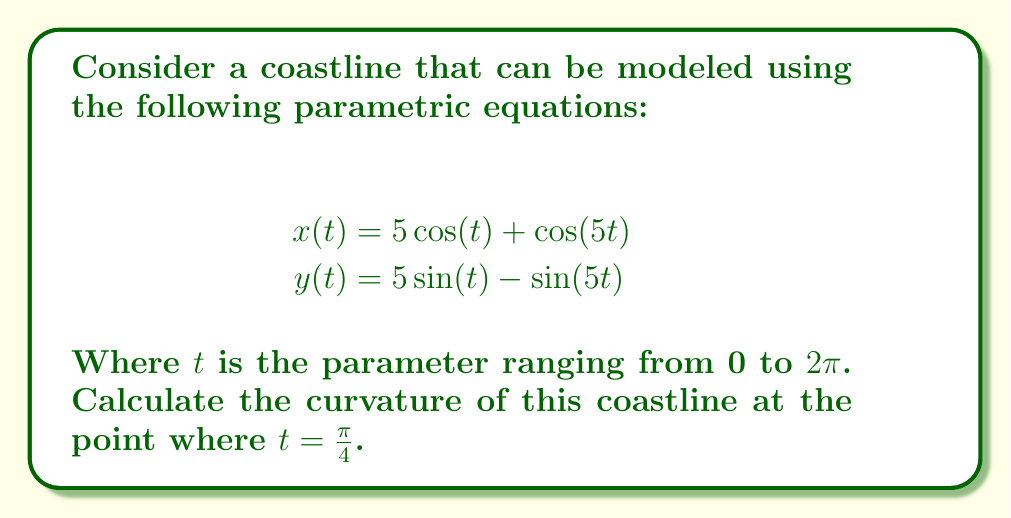Can you solve this math problem? To solve this problem, we'll follow these steps:

1) The formula for curvature ($\kappa$) of a parametric curve is:

   $$\kappa = \frac{|x'y'' - y'x''|}{(x'^2 + y'^2)^{3/2}}$$

2) Let's find the first and second derivatives of $x$ and $y$ with respect to $t$:

   $$x'(t) = -5\sin(t) - 5\sin(5t)$$
   $$y'(t) = 5\cos(t) - 5\cos(5t)$$
   $$x''(t) = -5\cos(t) - 25\cos(5t)$$
   $$y''(t) = -5\sin(t) + 25\sin(5t)$$

3) Now, we need to evaluate these at $t = \frac{\pi}{4}$:

   $$x'(\frac{\pi}{4}) = -5\sin(\frac{\pi}{4}) - 5\sin(\frac{5\pi}{4}) = -\frac{5\sqrt{2}}{2} + \frac{5\sqrt{2}}{2} = 0$$
   $$y'(\frac{\pi}{4}) = 5\cos(\frac{\pi}{4}) - 5\cos(\frac{5\pi}{4}) = \frac{5\sqrt{2}}{2} + \frac{5\sqrt{2}}{2} = 5\sqrt{2}$$
   $$x''(\frac{\pi}{4}) = -5\cos(\frac{\pi}{4}) - 25\cos(\frac{5\pi}{4}) = -\frac{5\sqrt{2}}{2} + \frac{25\sqrt{2}}{2} = 10\sqrt{2}$$
   $$y''(\frac{\pi}{4}) = -5\sin(\frac{\pi}{4}) + 25\sin(\frac{5\pi}{4}) = -\frac{5\sqrt{2}}{2} - \frac{25\sqrt{2}}{2} = -15\sqrt{2}$$

4) Now we can substitute these values into the curvature formula:

   $$\kappa = \frac{|0 \cdot (-15\sqrt{2}) - (5\sqrt{2}) \cdot (10\sqrt{2})|}{(0^2 + (5\sqrt{2})^2)^{3/2}}$$

5) Simplify:

   $$\kappa = \frac{|-100|}{(50)^{3/2}} = \frac{100}{50\sqrt{50}} = \frac{2}{\sqrt{50}} = \frac{2\sqrt{2}}{10}$$

Therefore, the curvature at $t = \frac{\pi}{4}$ is $\frac{2\sqrt{2}}{10}$.
Answer: $\frac{2\sqrt{2}}{10}$ 